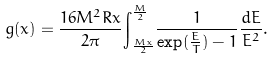<formula> <loc_0><loc_0><loc_500><loc_500>g ( x ) = \frac { 1 6 M ^ { 2 } R x } { 2 \pi } { \int } _ { \frac { M x } { 2 } } ^ { \frac { M } { 2 } } \frac { 1 } { \exp ( \frac { E } { T } ) - 1 } \frac { d E } { E ^ { 2 } } .</formula> 